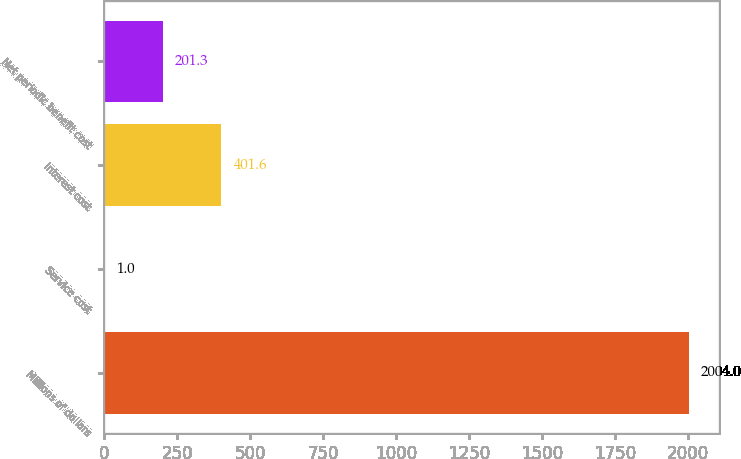Convert chart to OTSL. <chart><loc_0><loc_0><loc_500><loc_500><bar_chart><fcel>Millions of dollars<fcel>Service cost<fcel>Interest cost<fcel>Net periodic benefit cost<nl><fcel>2004<fcel>1<fcel>401.6<fcel>201.3<nl></chart> 